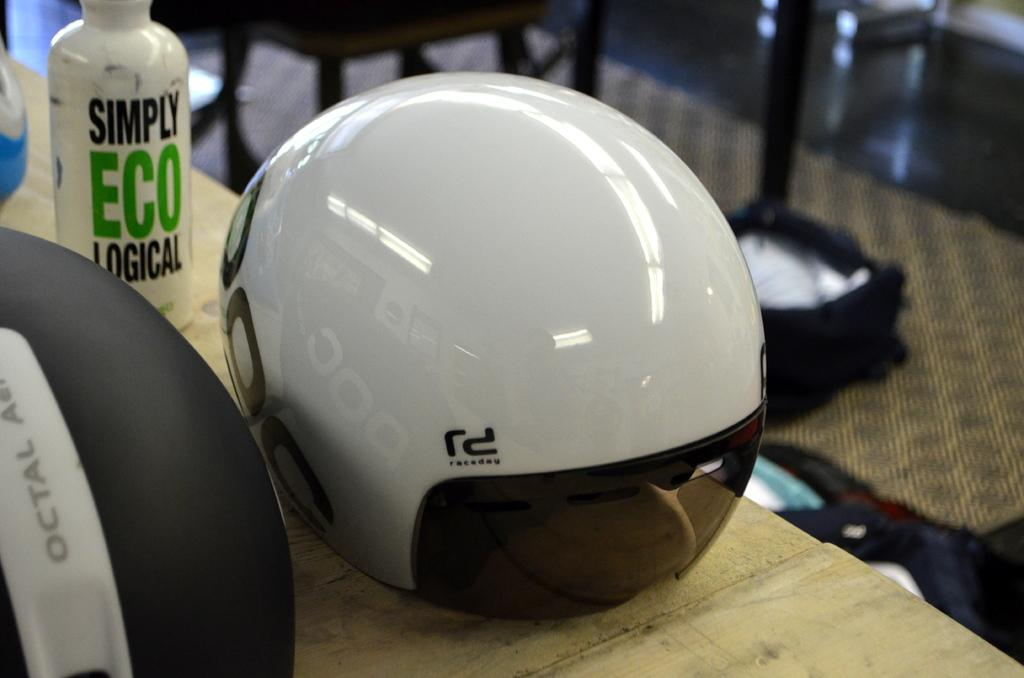What object is visible in the image that is typically used for head protection? There is a helmet in the image. Where is the helmet located in the image? The helmet is placed on a table. What other object can be seen on the table in the image? There is a bottle placed on the table in the image. What type of dust can be seen accumulating on the oven in the image? There is no oven or dust present in the image; it only features a helmet and a bottle on a table. 